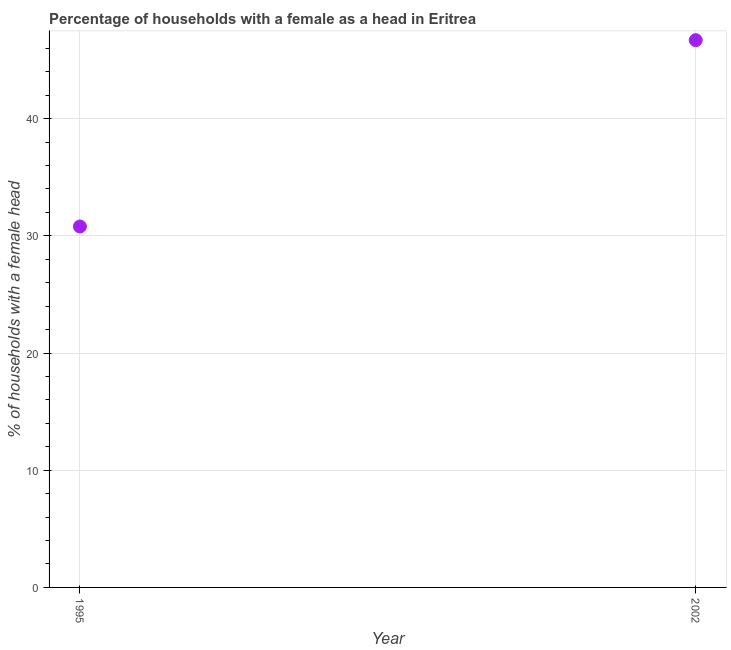What is the number of female supervised households in 2002?
Provide a succinct answer. 46.7. Across all years, what is the maximum number of female supervised households?
Provide a short and direct response. 46.7. Across all years, what is the minimum number of female supervised households?
Provide a succinct answer. 30.8. In which year was the number of female supervised households maximum?
Provide a succinct answer. 2002. In which year was the number of female supervised households minimum?
Keep it short and to the point. 1995. What is the sum of the number of female supervised households?
Offer a very short reply. 77.5. What is the difference between the number of female supervised households in 1995 and 2002?
Give a very brief answer. -15.9. What is the average number of female supervised households per year?
Offer a very short reply. 38.75. What is the median number of female supervised households?
Your answer should be very brief. 38.75. What is the ratio of the number of female supervised households in 1995 to that in 2002?
Your answer should be compact. 0.66. Is the number of female supervised households in 1995 less than that in 2002?
Provide a succinct answer. Yes. In how many years, is the number of female supervised households greater than the average number of female supervised households taken over all years?
Provide a short and direct response. 1. Does the number of female supervised households monotonically increase over the years?
Make the answer very short. Yes. Does the graph contain any zero values?
Make the answer very short. No. What is the title of the graph?
Offer a very short reply. Percentage of households with a female as a head in Eritrea. What is the label or title of the X-axis?
Make the answer very short. Year. What is the label or title of the Y-axis?
Offer a very short reply. % of households with a female head. What is the % of households with a female head in 1995?
Offer a terse response. 30.8. What is the % of households with a female head in 2002?
Make the answer very short. 46.7. What is the difference between the % of households with a female head in 1995 and 2002?
Your answer should be very brief. -15.9. What is the ratio of the % of households with a female head in 1995 to that in 2002?
Provide a succinct answer. 0.66. 